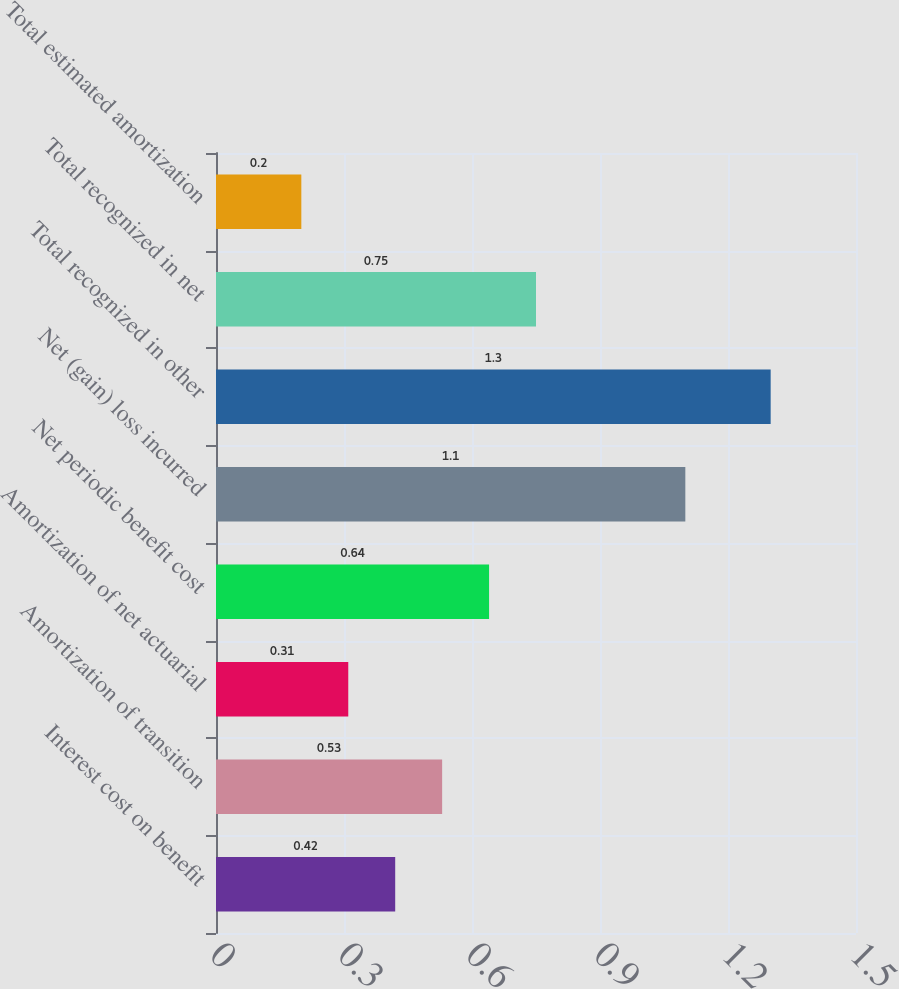Convert chart. <chart><loc_0><loc_0><loc_500><loc_500><bar_chart><fcel>Interest cost on benefit<fcel>Amortization of transition<fcel>Amortization of net actuarial<fcel>Net periodic benefit cost<fcel>Net (gain) loss incurred<fcel>Total recognized in other<fcel>Total recognized in net<fcel>Total estimated amortization<nl><fcel>0.42<fcel>0.53<fcel>0.31<fcel>0.64<fcel>1.1<fcel>1.3<fcel>0.75<fcel>0.2<nl></chart> 